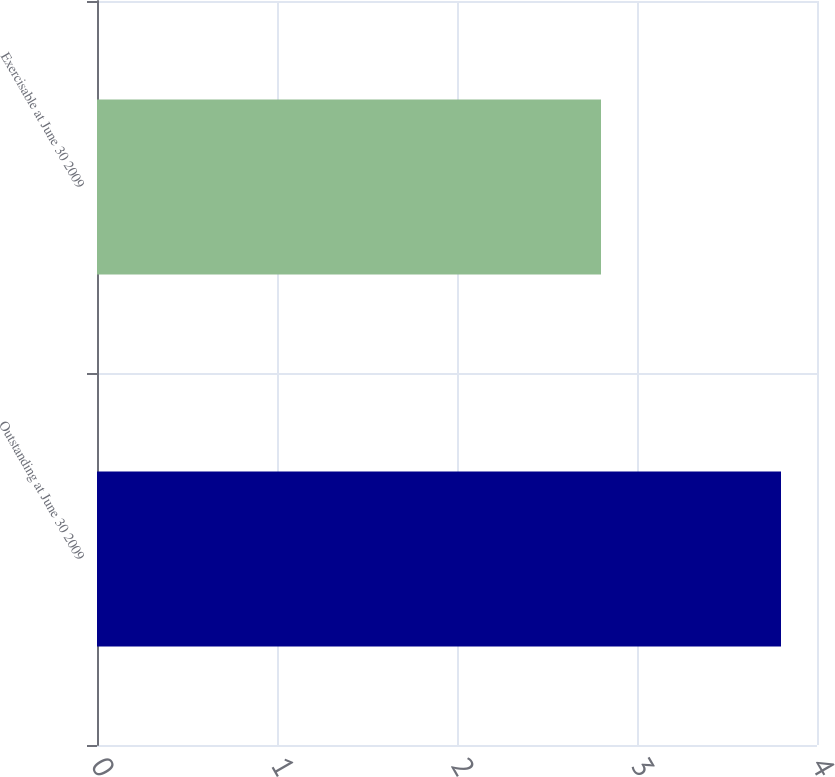Convert chart. <chart><loc_0><loc_0><loc_500><loc_500><bar_chart><fcel>Outstanding at June 30 2009<fcel>Exercisable at June 30 2009<nl><fcel>3.8<fcel>2.8<nl></chart> 